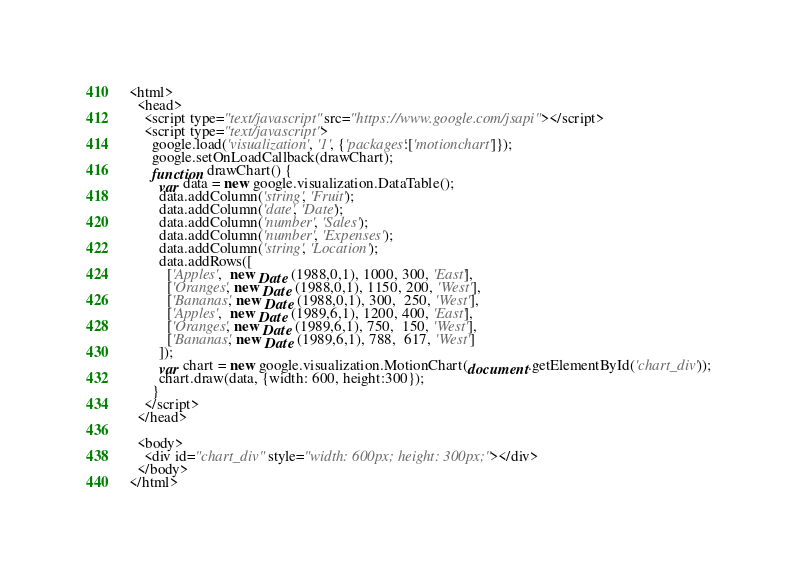<code> <loc_0><loc_0><loc_500><loc_500><_HTML_><html>
  <head>
    <script type="text/javascript" src="https://www.google.com/jsapi"></script>
    <script type="text/javascript">
      google.load('visualization', '1', {'packages':['motionchart']});
      google.setOnLoadCallback(drawChart);
      function drawChart() {
        var data = new google.visualization.DataTable();
        data.addColumn('string', 'Fruit');
        data.addColumn('date', 'Date');
        data.addColumn('number', 'Sales');
        data.addColumn('number', 'Expenses');
        data.addColumn('string', 'Location');
        data.addRows([
          ['Apples',  new Date (1988,0,1), 1000, 300, 'East'],
          ['Oranges', new Date (1988,0,1), 1150, 200, 'West'],
          ['Bananas', new Date (1988,0,1), 300,  250, 'West'],
          ['Apples',  new Date (1989,6,1), 1200, 400, 'East'],
          ['Oranges', new Date (1989,6,1), 750,  150, 'West'],
          ['Bananas', new Date (1989,6,1), 788,  617, 'West']
        ]);
        var chart = new google.visualization.MotionChart(document.getElementById('chart_div'));
        chart.draw(data, {width: 600, height:300});
      }
    </script>
  </head>

  <body>
    <div id="chart_div" style="width: 600px; height: 300px;"></div>
  </body>
</html>
</code> 